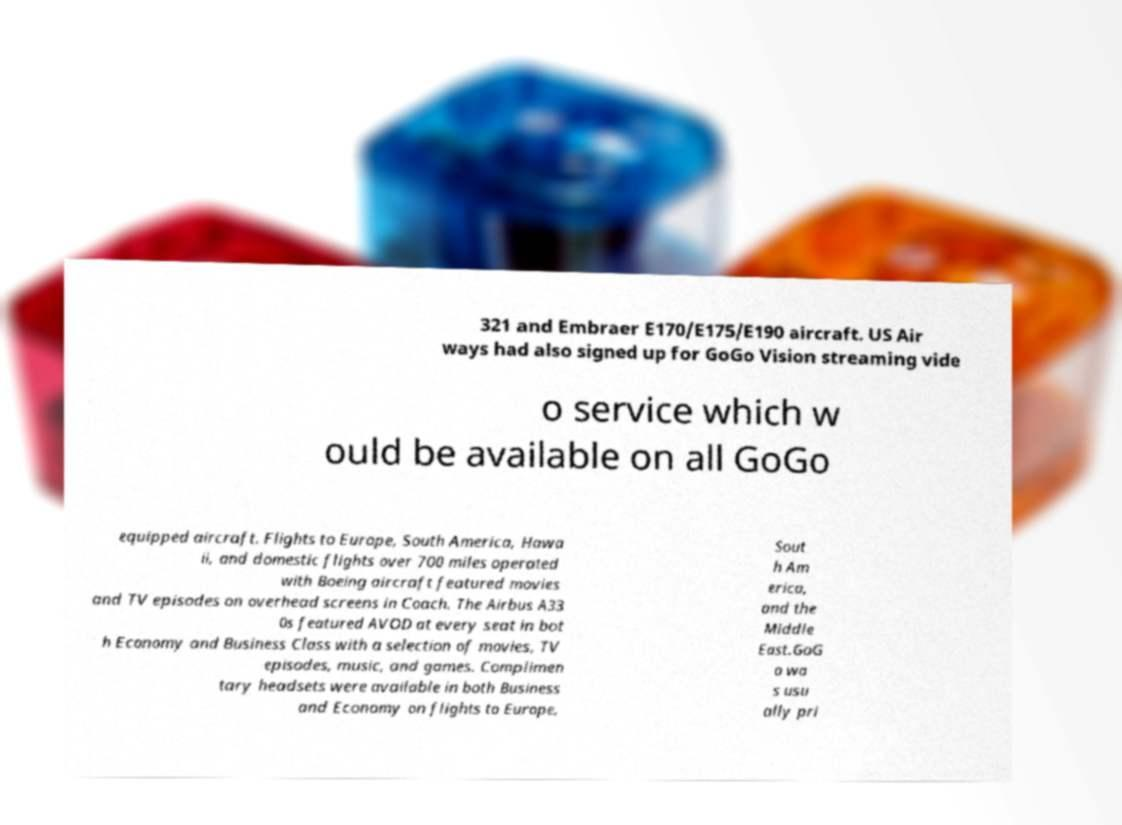Can you read and provide the text displayed in the image?This photo seems to have some interesting text. Can you extract and type it out for me? 321 and Embraer E170/E175/E190 aircraft. US Air ways had also signed up for GoGo Vision streaming vide o service which w ould be available on all GoGo equipped aircraft. Flights to Europe, South America, Hawa ii, and domestic flights over 700 miles operated with Boeing aircraft featured movies and TV episodes on overhead screens in Coach. The Airbus A33 0s featured AVOD at every seat in bot h Economy and Business Class with a selection of movies, TV episodes, music, and games. Complimen tary headsets were available in both Business and Economy on flights to Europe, Sout h Am erica, and the Middle East.GoG o wa s usu ally pri 